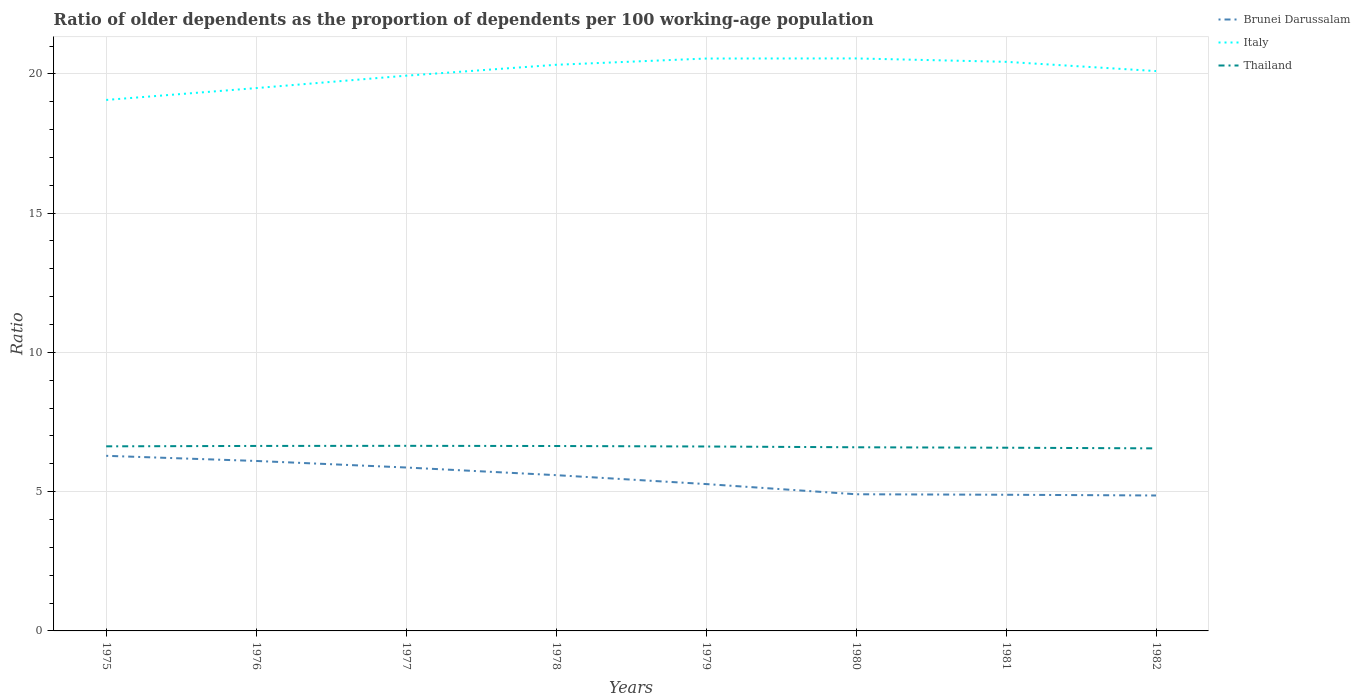How many different coloured lines are there?
Your response must be concise. 3. Across all years, what is the maximum age dependency ratio(old) in Brunei Darussalam?
Give a very brief answer. 4.86. In which year was the age dependency ratio(old) in Thailand maximum?
Your answer should be very brief. 1982. What is the total age dependency ratio(old) in Brunei Darussalam in the graph?
Offer a very short reply. 0.98. What is the difference between the highest and the second highest age dependency ratio(old) in Thailand?
Your response must be concise. 0.09. What is the difference between the highest and the lowest age dependency ratio(old) in Thailand?
Give a very brief answer. 5. Is the age dependency ratio(old) in Thailand strictly greater than the age dependency ratio(old) in Italy over the years?
Give a very brief answer. Yes. How many lines are there?
Keep it short and to the point. 3. What is the difference between two consecutive major ticks on the Y-axis?
Your answer should be very brief. 5. Are the values on the major ticks of Y-axis written in scientific E-notation?
Offer a very short reply. No. Does the graph contain any zero values?
Provide a short and direct response. No. Does the graph contain grids?
Give a very brief answer. Yes. How are the legend labels stacked?
Your response must be concise. Vertical. What is the title of the graph?
Ensure brevity in your answer.  Ratio of older dependents as the proportion of dependents per 100 working-age population. Does "France" appear as one of the legend labels in the graph?
Your answer should be very brief. No. What is the label or title of the Y-axis?
Provide a short and direct response. Ratio. What is the Ratio in Brunei Darussalam in 1975?
Your answer should be compact. 6.29. What is the Ratio in Italy in 1975?
Provide a short and direct response. 19.06. What is the Ratio of Thailand in 1975?
Offer a very short reply. 6.63. What is the Ratio in Brunei Darussalam in 1976?
Your answer should be very brief. 6.1. What is the Ratio in Italy in 1976?
Offer a very short reply. 19.49. What is the Ratio in Thailand in 1976?
Make the answer very short. 6.64. What is the Ratio of Brunei Darussalam in 1977?
Offer a terse response. 5.87. What is the Ratio in Italy in 1977?
Give a very brief answer. 19.93. What is the Ratio of Thailand in 1977?
Keep it short and to the point. 6.65. What is the Ratio in Brunei Darussalam in 1978?
Offer a terse response. 5.59. What is the Ratio of Italy in 1978?
Ensure brevity in your answer.  20.33. What is the Ratio of Thailand in 1978?
Your answer should be compact. 6.64. What is the Ratio in Brunei Darussalam in 1979?
Provide a short and direct response. 5.27. What is the Ratio of Italy in 1979?
Give a very brief answer. 20.55. What is the Ratio in Thailand in 1979?
Provide a succinct answer. 6.62. What is the Ratio of Brunei Darussalam in 1980?
Your answer should be very brief. 4.91. What is the Ratio of Italy in 1980?
Provide a succinct answer. 20.55. What is the Ratio in Thailand in 1980?
Make the answer very short. 6.59. What is the Ratio in Brunei Darussalam in 1981?
Provide a succinct answer. 4.89. What is the Ratio in Italy in 1981?
Offer a very short reply. 20.43. What is the Ratio in Thailand in 1981?
Make the answer very short. 6.58. What is the Ratio of Brunei Darussalam in 1982?
Offer a terse response. 4.86. What is the Ratio in Italy in 1982?
Keep it short and to the point. 20.1. What is the Ratio in Thailand in 1982?
Make the answer very short. 6.55. Across all years, what is the maximum Ratio of Brunei Darussalam?
Give a very brief answer. 6.29. Across all years, what is the maximum Ratio of Italy?
Your answer should be very brief. 20.55. Across all years, what is the maximum Ratio in Thailand?
Provide a short and direct response. 6.65. Across all years, what is the minimum Ratio of Brunei Darussalam?
Make the answer very short. 4.86. Across all years, what is the minimum Ratio in Italy?
Provide a short and direct response. 19.06. Across all years, what is the minimum Ratio of Thailand?
Ensure brevity in your answer.  6.55. What is the total Ratio of Brunei Darussalam in the graph?
Provide a short and direct response. 43.78. What is the total Ratio of Italy in the graph?
Offer a terse response. 160.45. What is the total Ratio in Thailand in the graph?
Provide a succinct answer. 52.9. What is the difference between the Ratio of Brunei Darussalam in 1975 and that in 1976?
Your answer should be very brief. 0.18. What is the difference between the Ratio in Italy in 1975 and that in 1976?
Your answer should be compact. -0.43. What is the difference between the Ratio of Thailand in 1975 and that in 1976?
Give a very brief answer. -0.01. What is the difference between the Ratio of Brunei Darussalam in 1975 and that in 1977?
Offer a very short reply. 0.42. What is the difference between the Ratio in Italy in 1975 and that in 1977?
Your response must be concise. -0.87. What is the difference between the Ratio in Thailand in 1975 and that in 1977?
Your response must be concise. -0.02. What is the difference between the Ratio of Brunei Darussalam in 1975 and that in 1978?
Ensure brevity in your answer.  0.69. What is the difference between the Ratio in Italy in 1975 and that in 1978?
Offer a very short reply. -1.26. What is the difference between the Ratio of Thailand in 1975 and that in 1978?
Your answer should be very brief. -0.01. What is the difference between the Ratio in Brunei Darussalam in 1975 and that in 1979?
Your response must be concise. 1.01. What is the difference between the Ratio in Italy in 1975 and that in 1979?
Give a very brief answer. -1.49. What is the difference between the Ratio of Thailand in 1975 and that in 1979?
Provide a short and direct response. 0.01. What is the difference between the Ratio of Brunei Darussalam in 1975 and that in 1980?
Your answer should be compact. 1.38. What is the difference between the Ratio in Italy in 1975 and that in 1980?
Your answer should be very brief. -1.49. What is the difference between the Ratio of Thailand in 1975 and that in 1980?
Your answer should be compact. 0.03. What is the difference between the Ratio of Brunei Darussalam in 1975 and that in 1981?
Offer a terse response. 1.4. What is the difference between the Ratio in Italy in 1975 and that in 1981?
Your response must be concise. -1.37. What is the difference between the Ratio in Thailand in 1975 and that in 1981?
Your answer should be very brief. 0.05. What is the difference between the Ratio of Brunei Darussalam in 1975 and that in 1982?
Make the answer very short. 1.42. What is the difference between the Ratio in Italy in 1975 and that in 1982?
Provide a short and direct response. -1.04. What is the difference between the Ratio of Thailand in 1975 and that in 1982?
Your answer should be compact. 0.07. What is the difference between the Ratio of Brunei Darussalam in 1976 and that in 1977?
Offer a terse response. 0.24. What is the difference between the Ratio in Italy in 1976 and that in 1977?
Provide a succinct answer. -0.45. What is the difference between the Ratio of Thailand in 1976 and that in 1977?
Ensure brevity in your answer.  -0. What is the difference between the Ratio in Brunei Darussalam in 1976 and that in 1978?
Your answer should be very brief. 0.51. What is the difference between the Ratio in Italy in 1976 and that in 1978?
Offer a very short reply. -0.84. What is the difference between the Ratio in Thailand in 1976 and that in 1978?
Your answer should be very brief. 0. What is the difference between the Ratio of Brunei Darussalam in 1976 and that in 1979?
Your answer should be very brief. 0.83. What is the difference between the Ratio of Italy in 1976 and that in 1979?
Provide a succinct answer. -1.06. What is the difference between the Ratio of Thailand in 1976 and that in 1979?
Provide a succinct answer. 0.02. What is the difference between the Ratio of Brunei Darussalam in 1976 and that in 1980?
Give a very brief answer. 1.2. What is the difference between the Ratio of Italy in 1976 and that in 1980?
Offer a very short reply. -1.06. What is the difference between the Ratio of Thailand in 1976 and that in 1980?
Your response must be concise. 0.05. What is the difference between the Ratio of Brunei Darussalam in 1976 and that in 1981?
Give a very brief answer. 1.21. What is the difference between the Ratio in Italy in 1976 and that in 1981?
Provide a succinct answer. -0.94. What is the difference between the Ratio in Thailand in 1976 and that in 1981?
Provide a short and direct response. 0.06. What is the difference between the Ratio of Brunei Darussalam in 1976 and that in 1982?
Offer a terse response. 1.24. What is the difference between the Ratio in Italy in 1976 and that in 1982?
Provide a succinct answer. -0.61. What is the difference between the Ratio in Thailand in 1976 and that in 1982?
Keep it short and to the point. 0.09. What is the difference between the Ratio of Brunei Darussalam in 1977 and that in 1978?
Ensure brevity in your answer.  0.27. What is the difference between the Ratio of Italy in 1977 and that in 1978?
Your answer should be very brief. -0.39. What is the difference between the Ratio of Thailand in 1977 and that in 1978?
Keep it short and to the point. 0.01. What is the difference between the Ratio of Brunei Darussalam in 1977 and that in 1979?
Make the answer very short. 0.59. What is the difference between the Ratio in Italy in 1977 and that in 1979?
Make the answer very short. -0.62. What is the difference between the Ratio of Thailand in 1977 and that in 1979?
Keep it short and to the point. 0.02. What is the difference between the Ratio of Brunei Darussalam in 1977 and that in 1980?
Ensure brevity in your answer.  0.96. What is the difference between the Ratio in Italy in 1977 and that in 1980?
Your response must be concise. -0.62. What is the difference between the Ratio of Thailand in 1977 and that in 1980?
Make the answer very short. 0.05. What is the difference between the Ratio in Brunei Darussalam in 1977 and that in 1981?
Your answer should be very brief. 0.98. What is the difference between the Ratio of Italy in 1977 and that in 1981?
Ensure brevity in your answer.  -0.5. What is the difference between the Ratio in Thailand in 1977 and that in 1981?
Give a very brief answer. 0.07. What is the difference between the Ratio in Brunei Darussalam in 1977 and that in 1982?
Provide a succinct answer. 1. What is the difference between the Ratio in Italy in 1977 and that in 1982?
Your answer should be very brief. -0.17. What is the difference between the Ratio of Thailand in 1977 and that in 1982?
Ensure brevity in your answer.  0.09. What is the difference between the Ratio of Brunei Darussalam in 1978 and that in 1979?
Your response must be concise. 0.32. What is the difference between the Ratio of Italy in 1978 and that in 1979?
Ensure brevity in your answer.  -0.22. What is the difference between the Ratio in Thailand in 1978 and that in 1979?
Your answer should be very brief. 0.02. What is the difference between the Ratio of Brunei Darussalam in 1978 and that in 1980?
Make the answer very short. 0.69. What is the difference between the Ratio in Italy in 1978 and that in 1980?
Your answer should be compact. -0.23. What is the difference between the Ratio of Thailand in 1978 and that in 1980?
Ensure brevity in your answer.  0.05. What is the difference between the Ratio of Brunei Darussalam in 1978 and that in 1981?
Give a very brief answer. 0.7. What is the difference between the Ratio in Italy in 1978 and that in 1981?
Provide a succinct answer. -0.11. What is the difference between the Ratio in Thailand in 1978 and that in 1981?
Give a very brief answer. 0.06. What is the difference between the Ratio of Brunei Darussalam in 1978 and that in 1982?
Your answer should be very brief. 0.73. What is the difference between the Ratio in Italy in 1978 and that in 1982?
Give a very brief answer. 0.23. What is the difference between the Ratio of Thailand in 1978 and that in 1982?
Your answer should be compact. 0.08. What is the difference between the Ratio in Brunei Darussalam in 1979 and that in 1980?
Offer a very short reply. 0.37. What is the difference between the Ratio of Italy in 1979 and that in 1980?
Offer a very short reply. -0. What is the difference between the Ratio of Thailand in 1979 and that in 1980?
Make the answer very short. 0.03. What is the difference between the Ratio in Brunei Darussalam in 1979 and that in 1981?
Your answer should be compact. 0.38. What is the difference between the Ratio of Italy in 1979 and that in 1981?
Offer a very short reply. 0.12. What is the difference between the Ratio of Thailand in 1979 and that in 1981?
Your answer should be very brief. 0.04. What is the difference between the Ratio of Brunei Darussalam in 1979 and that in 1982?
Offer a terse response. 0.41. What is the difference between the Ratio in Italy in 1979 and that in 1982?
Your response must be concise. 0.45. What is the difference between the Ratio of Thailand in 1979 and that in 1982?
Give a very brief answer. 0.07. What is the difference between the Ratio in Brunei Darussalam in 1980 and that in 1981?
Provide a short and direct response. 0.02. What is the difference between the Ratio of Italy in 1980 and that in 1981?
Ensure brevity in your answer.  0.12. What is the difference between the Ratio of Thailand in 1980 and that in 1981?
Make the answer very short. 0.02. What is the difference between the Ratio in Brunei Darussalam in 1980 and that in 1982?
Your response must be concise. 0.04. What is the difference between the Ratio in Italy in 1980 and that in 1982?
Your response must be concise. 0.45. What is the difference between the Ratio of Thailand in 1980 and that in 1982?
Provide a short and direct response. 0.04. What is the difference between the Ratio in Brunei Darussalam in 1981 and that in 1982?
Offer a very short reply. 0.03. What is the difference between the Ratio of Italy in 1981 and that in 1982?
Make the answer very short. 0.33. What is the difference between the Ratio in Thailand in 1981 and that in 1982?
Keep it short and to the point. 0.02. What is the difference between the Ratio in Brunei Darussalam in 1975 and the Ratio in Italy in 1976?
Give a very brief answer. -13.2. What is the difference between the Ratio of Brunei Darussalam in 1975 and the Ratio of Thailand in 1976?
Keep it short and to the point. -0.35. What is the difference between the Ratio in Italy in 1975 and the Ratio in Thailand in 1976?
Your answer should be compact. 12.42. What is the difference between the Ratio in Brunei Darussalam in 1975 and the Ratio in Italy in 1977?
Keep it short and to the point. -13.65. What is the difference between the Ratio in Brunei Darussalam in 1975 and the Ratio in Thailand in 1977?
Give a very brief answer. -0.36. What is the difference between the Ratio in Italy in 1975 and the Ratio in Thailand in 1977?
Your response must be concise. 12.42. What is the difference between the Ratio of Brunei Darussalam in 1975 and the Ratio of Italy in 1978?
Offer a terse response. -14.04. What is the difference between the Ratio of Brunei Darussalam in 1975 and the Ratio of Thailand in 1978?
Offer a terse response. -0.35. What is the difference between the Ratio of Italy in 1975 and the Ratio of Thailand in 1978?
Your answer should be very brief. 12.43. What is the difference between the Ratio in Brunei Darussalam in 1975 and the Ratio in Italy in 1979?
Make the answer very short. -14.26. What is the difference between the Ratio of Brunei Darussalam in 1975 and the Ratio of Thailand in 1979?
Offer a very short reply. -0.33. What is the difference between the Ratio in Italy in 1975 and the Ratio in Thailand in 1979?
Offer a terse response. 12.44. What is the difference between the Ratio of Brunei Darussalam in 1975 and the Ratio of Italy in 1980?
Provide a succinct answer. -14.27. What is the difference between the Ratio of Brunei Darussalam in 1975 and the Ratio of Thailand in 1980?
Offer a terse response. -0.31. What is the difference between the Ratio in Italy in 1975 and the Ratio in Thailand in 1980?
Provide a short and direct response. 12.47. What is the difference between the Ratio of Brunei Darussalam in 1975 and the Ratio of Italy in 1981?
Your answer should be very brief. -14.15. What is the difference between the Ratio of Brunei Darussalam in 1975 and the Ratio of Thailand in 1981?
Give a very brief answer. -0.29. What is the difference between the Ratio of Italy in 1975 and the Ratio of Thailand in 1981?
Offer a terse response. 12.49. What is the difference between the Ratio in Brunei Darussalam in 1975 and the Ratio in Italy in 1982?
Provide a short and direct response. -13.81. What is the difference between the Ratio in Brunei Darussalam in 1975 and the Ratio in Thailand in 1982?
Make the answer very short. -0.27. What is the difference between the Ratio in Italy in 1975 and the Ratio in Thailand in 1982?
Your answer should be compact. 12.51. What is the difference between the Ratio of Brunei Darussalam in 1976 and the Ratio of Italy in 1977?
Ensure brevity in your answer.  -13.83. What is the difference between the Ratio in Brunei Darussalam in 1976 and the Ratio in Thailand in 1977?
Keep it short and to the point. -0.54. What is the difference between the Ratio in Italy in 1976 and the Ratio in Thailand in 1977?
Offer a terse response. 12.84. What is the difference between the Ratio in Brunei Darussalam in 1976 and the Ratio in Italy in 1978?
Your answer should be compact. -14.22. What is the difference between the Ratio of Brunei Darussalam in 1976 and the Ratio of Thailand in 1978?
Provide a short and direct response. -0.54. What is the difference between the Ratio in Italy in 1976 and the Ratio in Thailand in 1978?
Your response must be concise. 12.85. What is the difference between the Ratio of Brunei Darussalam in 1976 and the Ratio of Italy in 1979?
Make the answer very short. -14.45. What is the difference between the Ratio of Brunei Darussalam in 1976 and the Ratio of Thailand in 1979?
Provide a succinct answer. -0.52. What is the difference between the Ratio of Italy in 1976 and the Ratio of Thailand in 1979?
Your answer should be compact. 12.87. What is the difference between the Ratio of Brunei Darussalam in 1976 and the Ratio of Italy in 1980?
Ensure brevity in your answer.  -14.45. What is the difference between the Ratio of Brunei Darussalam in 1976 and the Ratio of Thailand in 1980?
Your answer should be very brief. -0.49. What is the difference between the Ratio of Italy in 1976 and the Ratio of Thailand in 1980?
Give a very brief answer. 12.9. What is the difference between the Ratio of Brunei Darussalam in 1976 and the Ratio of Italy in 1981?
Offer a terse response. -14.33. What is the difference between the Ratio in Brunei Darussalam in 1976 and the Ratio in Thailand in 1981?
Give a very brief answer. -0.48. What is the difference between the Ratio in Italy in 1976 and the Ratio in Thailand in 1981?
Give a very brief answer. 12.91. What is the difference between the Ratio in Brunei Darussalam in 1976 and the Ratio in Italy in 1982?
Make the answer very short. -14. What is the difference between the Ratio in Brunei Darussalam in 1976 and the Ratio in Thailand in 1982?
Provide a succinct answer. -0.45. What is the difference between the Ratio of Italy in 1976 and the Ratio of Thailand in 1982?
Your response must be concise. 12.94. What is the difference between the Ratio of Brunei Darussalam in 1977 and the Ratio of Italy in 1978?
Provide a succinct answer. -14.46. What is the difference between the Ratio in Brunei Darussalam in 1977 and the Ratio in Thailand in 1978?
Offer a terse response. -0.77. What is the difference between the Ratio of Italy in 1977 and the Ratio of Thailand in 1978?
Provide a succinct answer. 13.3. What is the difference between the Ratio of Brunei Darussalam in 1977 and the Ratio of Italy in 1979?
Offer a very short reply. -14.68. What is the difference between the Ratio of Brunei Darussalam in 1977 and the Ratio of Thailand in 1979?
Ensure brevity in your answer.  -0.75. What is the difference between the Ratio in Italy in 1977 and the Ratio in Thailand in 1979?
Give a very brief answer. 13.31. What is the difference between the Ratio of Brunei Darussalam in 1977 and the Ratio of Italy in 1980?
Provide a succinct answer. -14.69. What is the difference between the Ratio of Brunei Darussalam in 1977 and the Ratio of Thailand in 1980?
Keep it short and to the point. -0.73. What is the difference between the Ratio in Italy in 1977 and the Ratio in Thailand in 1980?
Ensure brevity in your answer.  13.34. What is the difference between the Ratio of Brunei Darussalam in 1977 and the Ratio of Italy in 1981?
Offer a terse response. -14.57. What is the difference between the Ratio in Brunei Darussalam in 1977 and the Ratio in Thailand in 1981?
Provide a succinct answer. -0.71. What is the difference between the Ratio of Italy in 1977 and the Ratio of Thailand in 1981?
Provide a succinct answer. 13.36. What is the difference between the Ratio in Brunei Darussalam in 1977 and the Ratio in Italy in 1982?
Your answer should be very brief. -14.23. What is the difference between the Ratio of Brunei Darussalam in 1977 and the Ratio of Thailand in 1982?
Your response must be concise. -0.69. What is the difference between the Ratio of Italy in 1977 and the Ratio of Thailand in 1982?
Offer a terse response. 13.38. What is the difference between the Ratio in Brunei Darussalam in 1978 and the Ratio in Italy in 1979?
Offer a very short reply. -14.96. What is the difference between the Ratio of Brunei Darussalam in 1978 and the Ratio of Thailand in 1979?
Ensure brevity in your answer.  -1.03. What is the difference between the Ratio in Italy in 1978 and the Ratio in Thailand in 1979?
Provide a succinct answer. 13.7. What is the difference between the Ratio of Brunei Darussalam in 1978 and the Ratio of Italy in 1980?
Your response must be concise. -14.96. What is the difference between the Ratio in Brunei Darussalam in 1978 and the Ratio in Thailand in 1980?
Your response must be concise. -1. What is the difference between the Ratio in Italy in 1978 and the Ratio in Thailand in 1980?
Make the answer very short. 13.73. What is the difference between the Ratio of Brunei Darussalam in 1978 and the Ratio of Italy in 1981?
Offer a very short reply. -14.84. What is the difference between the Ratio of Brunei Darussalam in 1978 and the Ratio of Thailand in 1981?
Offer a terse response. -0.98. What is the difference between the Ratio in Italy in 1978 and the Ratio in Thailand in 1981?
Provide a succinct answer. 13.75. What is the difference between the Ratio of Brunei Darussalam in 1978 and the Ratio of Italy in 1982?
Provide a short and direct response. -14.51. What is the difference between the Ratio of Brunei Darussalam in 1978 and the Ratio of Thailand in 1982?
Provide a short and direct response. -0.96. What is the difference between the Ratio of Italy in 1978 and the Ratio of Thailand in 1982?
Ensure brevity in your answer.  13.77. What is the difference between the Ratio of Brunei Darussalam in 1979 and the Ratio of Italy in 1980?
Keep it short and to the point. -15.28. What is the difference between the Ratio of Brunei Darussalam in 1979 and the Ratio of Thailand in 1980?
Keep it short and to the point. -1.32. What is the difference between the Ratio of Italy in 1979 and the Ratio of Thailand in 1980?
Offer a very short reply. 13.96. What is the difference between the Ratio in Brunei Darussalam in 1979 and the Ratio in Italy in 1981?
Give a very brief answer. -15.16. What is the difference between the Ratio in Brunei Darussalam in 1979 and the Ratio in Thailand in 1981?
Provide a short and direct response. -1.3. What is the difference between the Ratio of Italy in 1979 and the Ratio of Thailand in 1981?
Your answer should be very brief. 13.97. What is the difference between the Ratio in Brunei Darussalam in 1979 and the Ratio in Italy in 1982?
Provide a succinct answer. -14.83. What is the difference between the Ratio in Brunei Darussalam in 1979 and the Ratio in Thailand in 1982?
Keep it short and to the point. -1.28. What is the difference between the Ratio in Italy in 1979 and the Ratio in Thailand in 1982?
Offer a very short reply. 14. What is the difference between the Ratio of Brunei Darussalam in 1980 and the Ratio of Italy in 1981?
Offer a very short reply. -15.53. What is the difference between the Ratio in Brunei Darussalam in 1980 and the Ratio in Thailand in 1981?
Offer a very short reply. -1.67. What is the difference between the Ratio of Italy in 1980 and the Ratio of Thailand in 1981?
Offer a very short reply. 13.98. What is the difference between the Ratio in Brunei Darussalam in 1980 and the Ratio in Italy in 1982?
Offer a terse response. -15.19. What is the difference between the Ratio in Brunei Darussalam in 1980 and the Ratio in Thailand in 1982?
Provide a succinct answer. -1.65. What is the difference between the Ratio of Brunei Darussalam in 1981 and the Ratio of Italy in 1982?
Your response must be concise. -15.21. What is the difference between the Ratio in Brunei Darussalam in 1981 and the Ratio in Thailand in 1982?
Make the answer very short. -1.67. What is the difference between the Ratio in Italy in 1981 and the Ratio in Thailand in 1982?
Make the answer very short. 13.88. What is the average Ratio of Brunei Darussalam per year?
Your answer should be very brief. 5.47. What is the average Ratio of Italy per year?
Make the answer very short. 20.06. What is the average Ratio of Thailand per year?
Make the answer very short. 6.61. In the year 1975, what is the difference between the Ratio of Brunei Darussalam and Ratio of Italy?
Make the answer very short. -12.78. In the year 1975, what is the difference between the Ratio in Brunei Darussalam and Ratio in Thailand?
Make the answer very short. -0.34. In the year 1975, what is the difference between the Ratio of Italy and Ratio of Thailand?
Make the answer very short. 12.44. In the year 1976, what is the difference between the Ratio in Brunei Darussalam and Ratio in Italy?
Make the answer very short. -13.39. In the year 1976, what is the difference between the Ratio of Brunei Darussalam and Ratio of Thailand?
Provide a short and direct response. -0.54. In the year 1976, what is the difference between the Ratio of Italy and Ratio of Thailand?
Your response must be concise. 12.85. In the year 1977, what is the difference between the Ratio in Brunei Darussalam and Ratio in Italy?
Your response must be concise. -14.07. In the year 1977, what is the difference between the Ratio in Brunei Darussalam and Ratio in Thailand?
Offer a terse response. -0.78. In the year 1977, what is the difference between the Ratio of Italy and Ratio of Thailand?
Ensure brevity in your answer.  13.29. In the year 1978, what is the difference between the Ratio of Brunei Darussalam and Ratio of Italy?
Keep it short and to the point. -14.73. In the year 1978, what is the difference between the Ratio in Brunei Darussalam and Ratio in Thailand?
Your answer should be compact. -1.05. In the year 1978, what is the difference between the Ratio in Italy and Ratio in Thailand?
Keep it short and to the point. 13.69. In the year 1979, what is the difference between the Ratio of Brunei Darussalam and Ratio of Italy?
Your answer should be very brief. -15.28. In the year 1979, what is the difference between the Ratio in Brunei Darussalam and Ratio in Thailand?
Your answer should be very brief. -1.35. In the year 1979, what is the difference between the Ratio of Italy and Ratio of Thailand?
Ensure brevity in your answer.  13.93. In the year 1980, what is the difference between the Ratio of Brunei Darussalam and Ratio of Italy?
Give a very brief answer. -15.65. In the year 1980, what is the difference between the Ratio of Brunei Darussalam and Ratio of Thailand?
Make the answer very short. -1.69. In the year 1980, what is the difference between the Ratio in Italy and Ratio in Thailand?
Your answer should be compact. 13.96. In the year 1981, what is the difference between the Ratio of Brunei Darussalam and Ratio of Italy?
Make the answer very short. -15.54. In the year 1981, what is the difference between the Ratio of Brunei Darussalam and Ratio of Thailand?
Your answer should be very brief. -1.69. In the year 1981, what is the difference between the Ratio of Italy and Ratio of Thailand?
Give a very brief answer. 13.86. In the year 1982, what is the difference between the Ratio in Brunei Darussalam and Ratio in Italy?
Ensure brevity in your answer.  -15.24. In the year 1982, what is the difference between the Ratio in Brunei Darussalam and Ratio in Thailand?
Your response must be concise. -1.69. In the year 1982, what is the difference between the Ratio of Italy and Ratio of Thailand?
Make the answer very short. 13.55. What is the ratio of the Ratio of Brunei Darussalam in 1975 to that in 1976?
Give a very brief answer. 1.03. What is the ratio of the Ratio in Italy in 1975 to that in 1976?
Your answer should be compact. 0.98. What is the ratio of the Ratio of Thailand in 1975 to that in 1976?
Offer a terse response. 1. What is the ratio of the Ratio in Brunei Darussalam in 1975 to that in 1977?
Keep it short and to the point. 1.07. What is the ratio of the Ratio of Italy in 1975 to that in 1977?
Your answer should be very brief. 0.96. What is the ratio of the Ratio of Brunei Darussalam in 1975 to that in 1978?
Provide a short and direct response. 1.12. What is the ratio of the Ratio in Italy in 1975 to that in 1978?
Provide a short and direct response. 0.94. What is the ratio of the Ratio in Thailand in 1975 to that in 1978?
Offer a terse response. 1. What is the ratio of the Ratio of Brunei Darussalam in 1975 to that in 1979?
Provide a succinct answer. 1.19. What is the ratio of the Ratio of Italy in 1975 to that in 1979?
Make the answer very short. 0.93. What is the ratio of the Ratio of Brunei Darussalam in 1975 to that in 1980?
Give a very brief answer. 1.28. What is the ratio of the Ratio of Italy in 1975 to that in 1980?
Ensure brevity in your answer.  0.93. What is the ratio of the Ratio in Thailand in 1975 to that in 1980?
Provide a short and direct response. 1.01. What is the ratio of the Ratio of Brunei Darussalam in 1975 to that in 1981?
Provide a succinct answer. 1.29. What is the ratio of the Ratio of Italy in 1975 to that in 1981?
Your answer should be very brief. 0.93. What is the ratio of the Ratio in Thailand in 1975 to that in 1981?
Offer a very short reply. 1.01. What is the ratio of the Ratio in Brunei Darussalam in 1975 to that in 1982?
Offer a terse response. 1.29. What is the ratio of the Ratio of Italy in 1975 to that in 1982?
Make the answer very short. 0.95. What is the ratio of the Ratio in Thailand in 1975 to that in 1982?
Make the answer very short. 1.01. What is the ratio of the Ratio of Brunei Darussalam in 1976 to that in 1977?
Your answer should be very brief. 1.04. What is the ratio of the Ratio in Italy in 1976 to that in 1977?
Ensure brevity in your answer.  0.98. What is the ratio of the Ratio of Thailand in 1976 to that in 1977?
Offer a very short reply. 1. What is the ratio of the Ratio in Brunei Darussalam in 1976 to that in 1978?
Your answer should be compact. 1.09. What is the ratio of the Ratio of Italy in 1976 to that in 1978?
Provide a succinct answer. 0.96. What is the ratio of the Ratio in Brunei Darussalam in 1976 to that in 1979?
Your answer should be very brief. 1.16. What is the ratio of the Ratio of Italy in 1976 to that in 1979?
Make the answer very short. 0.95. What is the ratio of the Ratio in Thailand in 1976 to that in 1979?
Provide a short and direct response. 1. What is the ratio of the Ratio of Brunei Darussalam in 1976 to that in 1980?
Offer a terse response. 1.24. What is the ratio of the Ratio in Italy in 1976 to that in 1980?
Keep it short and to the point. 0.95. What is the ratio of the Ratio in Thailand in 1976 to that in 1980?
Offer a very short reply. 1.01. What is the ratio of the Ratio of Brunei Darussalam in 1976 to that in 1981?
Ensure brevity in your answer.  1.25. What is the ratio of the Ratio of Italy in 1976 to that in 1981?
Offer a terse response. 0.95. What is the ratio of the Ratio of Thailand in 1976 to that in 1981?
Provide a succinct answer. 1.01. What is the ratio of the Ratio of Brunei Darussalam in 1976 to that in 1982?
Provide a short and direct response. 1.25. What is the ratio of the Ratio of Italy in 1976 to that in 1982?
Provide a succinct answer. 0.97. What is the ratio of the Ratio of Thailand in 1976 to that in 1982?
Keep it short and to the point. 1.01. What is the ratio of the Ratio in Brunei Darussalam in 1977 to that in 1978?
Your response must be concise. 1.05. What is the ratio of the Ratio in Italy in 1977 to that in 1978?
Provide a succinct answer. 0.98. What is the ratio of the Ratio of Thailand in 1977 to that in 1978?
Provide a short and direct response. 1. What is the ratio of the Ratio in Brunei Darussalam in 1977 to that in 1979?
Your answer should be very brief. 1.11. What is the ratio of the Ratio in Thailand in 1977 to that in 1979?
Keep it short and to the point. 1. What is the ratio of the Ratio of Brunei Darussalam in 1977 to that in 1980?
Keep it short and to the point. 1.2. What is the ratio of the Ratio in Italy in 1977 to that in 1980?
Provide a succinct answer. 0.97. What is the ratio of the Ratio in Thailand in 1977 to that in 1980?
Offer a very short reply. 1.01. What is the ratio of the Ratio in Brunei Darussalam in 1977 to that in 1981?
Your response must be concise. 1.2. What is the ratio of the Ratio of Italy in 1977 to that in 1981?
Your answer should be very brief. 0.98. What is the ratio of the Ratio of Thailand in 1977 to that in 1981?
Give a very brief answer. 1.01. What is the ratio of the Ratio in Brunei Darussalam in 1977 to that in 1982?
Ensure brevity in your answer.  1.21. What is the ratio of the Ratio of Italy in 1977 to that in 1982?
Make the answer very short. 0.99. What is the ratio of the Ratio in Thailand in 1977 to that in 1982?
Offer a terse response. 1.01. What is the ratio of the Ratio of Brunei Darussalam in 1978 to that in 1979?
Provide a succinct answer. 1.06. What is the ratio of the Ratio in Brunei Darussalam in 1978 to that in 1980?
Keep it short and to the point. 1.14. What is the ratio of the Ratio of Italy in 1978 to that in 1980?
Provide a short and direct response. 0.99. What is the ratio of the Ratio of Thailand in 1978 to that in 1980?
Your answer should be very brief. 1.01. What is the ratio of the Ratio of Brunei Darussalam in 1978 to that in 1981?
Keep it short and to the point. 1.14. What is the ratio of the Ratio in Italy in 1978 to that in 1981?
Ensure brevity in your answer.  0.99. What is the ratio of the Ratio of Thailand in 1978 to that in 1981?
Offer a very short reply. 1.01. What is the ratio of the Ratio of Brunei Darussalam in 1978 to that in 1982?
Give a very brief answer. 1.15. What is the ratio of the Ratio in Italy in 1978 to that in 1982?
Give a very brief answer. 1.01. What is the ratio of the Ratio of Thailand in 1978 to that in 1982?
Your answer should be very brief. 1.01. What is the ratio of the Ratio in Brunei Darussalam in 1979 to that in 1980?
Make the answer very short. 1.07. What is the ratio of the Ratio of Thailand in 1979 to that in 1980?
Provide a short and direct response. 1. What is the ratio of the Ratio in Brunei Darussalam in 1979 to that in 1981?
Provide a succinct answer. 1.08. What is the ratio of the Ratio in Brunei Darussalam in 1979 to that in 1982?
Provide a succinct answer. 1.08. What is the ratio of the Ratio in Italy in 1979 to that in 1982?
Your response must be concise. 1.02. What is the ratio of the Ratio of Thailand in 1979 to that in 1982?
Give a very brief answer. 1.01. What is the ratio of the Ratio in Brunei Darussalam in 1980 to that in 1981?
Provide a short and direct response. 1. What is the ratio of the Ratio in Italy in 1980 to that in 1981?
Make the answer very short. 1.01. What is the ratio of the Ratio in Thailand in 1980 to that in 1981?
Ensure brevity in your answer.  1. What is the ratio of the Ratio in Brunei Darussalam in 1980 to that in 1982?
Offer a terse response. 1.01. What is the ratio of the Ratio in Italy in 1980 to that in 1982?
Your answer should be compact. 1.02. What is the ratio of the Ratio of Thailand in 1980 to that in 1982?
Offer a very short reply. 1.01. What is the ratio of the Ratio in Brunei Darussalam in 1981 to that in 1982?
Your answer should be compact. 1.01. What is the ratio of the Ratio of Italy in 1981 to that in 1982?
Provide a succinct answer. 1.02. What is the difference between the highest and the second highest Ratio in Brunei Darussalam?
Ensure brevity in your answer.  0.18. What is the difference between the highest and the second highest Ratio of Italy?
Your answer should be compact. 0. What is the difference between the highest and the second highest Ratio in Thailand?
Your answer should be compact. 0. What is the difference between the highest and the lowest Ratio in Brunei Darussalam?
Offer a very short reply. 1.42. What is the difference between the highest and the lowest Ratio of Italy?
Ensure brevity in your answer.  1.49. What is the difference between the highest and the lowest Ratio of Thailand?
Your answer should be very brief. 0.09. 